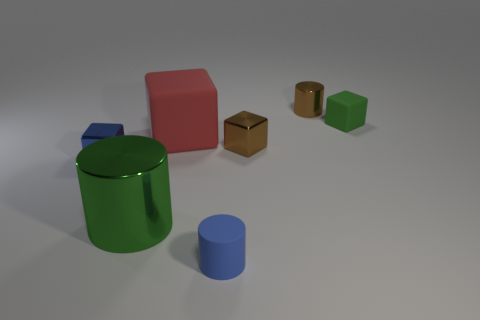Subtract all large green shiny cylinders. How many cylinders are left? 2 Add 1 small metal spheres. How many objects exist? 8 Subtract all brown blocks. How many blocks are left? 3 Subtract 3 blocks. How many blocks are left? 1 Subtract all cylinders. How many objects are left? 4 Add 6 small matte blocks. How many small matte blocks are left? 7 Add 2 gray matte blocks. How many gray matte blocks exist? 2 Subtract 0 red cylinders. How many objects are left? 7 Subtract all gray blocks. Subtract all gray cylinders. How many blocks are left? 4 Subtract all metal objects. Subtract all tiny purple objects. How many objects are left? 3 